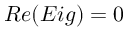<formula> <loc_0><loc_0><loc_500><loc_500>R e ( E i g ) = 0</formula> 